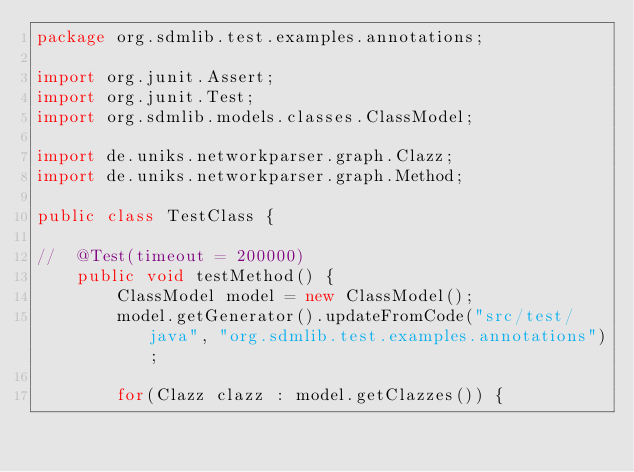<code> <loc_0><loc_0><loc_500><loc_500><_Java_>package org.sdmlib.test.examples.annotations;

import org.junit.Assert;
import org.junit.Test;
import org.sdmlib.models.classes.ClassModel;

import de.uniks.networkparser.graph.Clazz;
import de.uniks.networkparser.graph.Method;

public class TestClass {

//	@Test(timeout = 200000)
	public void testMethod() {
		ClassModel model = new ClassModel();
		model.getGenerator().updateFromCode("src/test/java", "org.sdmlib.test.examples.annotations");
		
		for(Clazz clazz : model.getClazzes()) {</code> 